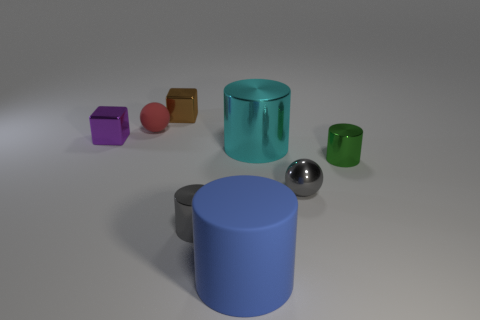What can you tell me about the lighting in this scene? The lighting in this scene appears to be soft and diffused, likely coming from a source above and slightly in front of the objects, creating gentle shadows and subtle highlights that enhance the three-dimensional look of the objects. 